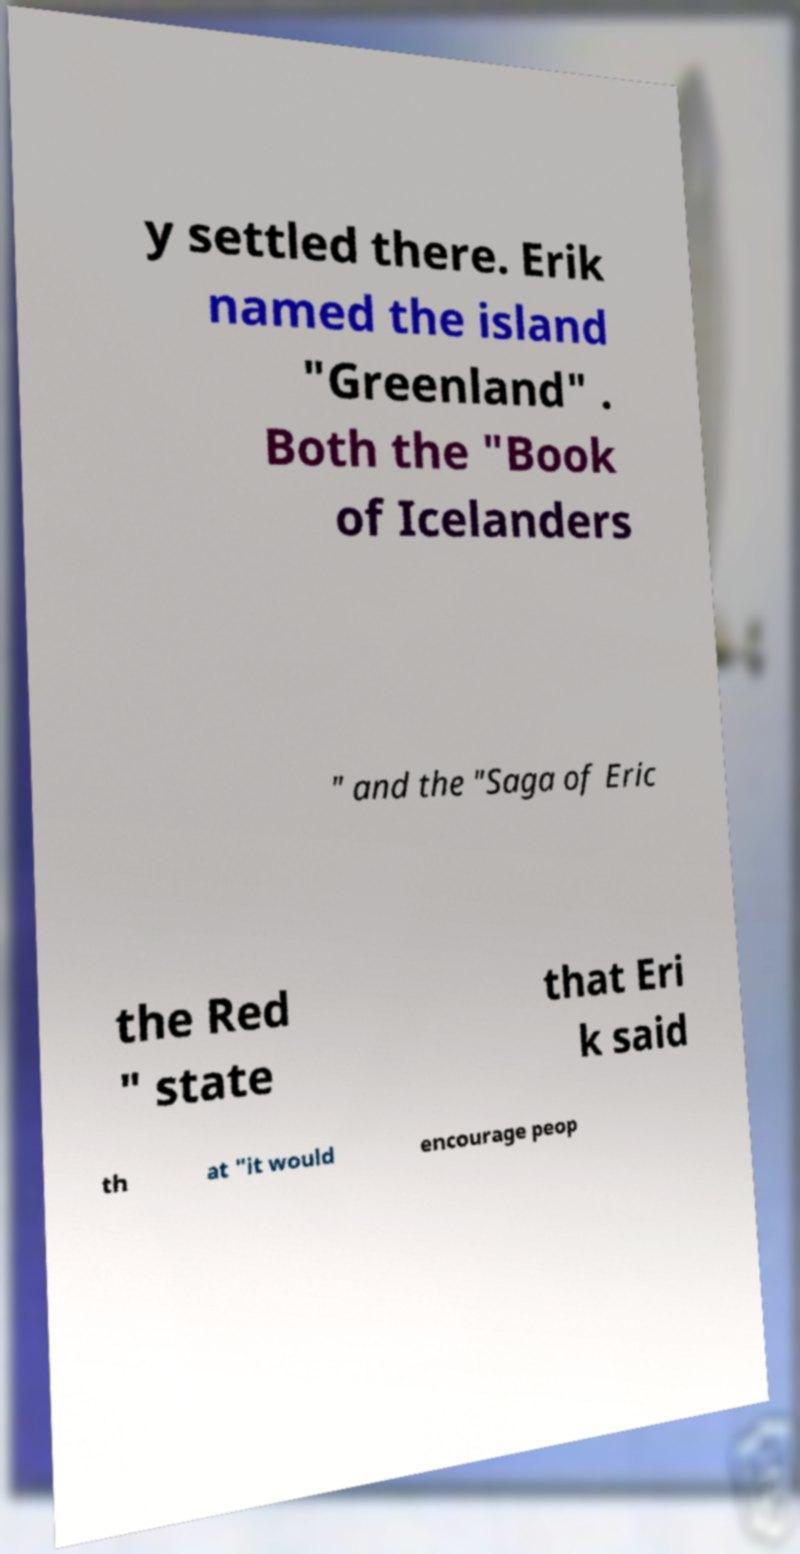What messages or text are displayed in this image? I need them in a readable, typed format. y settled there. Erik named the island "Greenland" . Both the "Book of Icelanders " and the "Saga of Eric the Red " state that Eri k said th at "it would encourage peop 